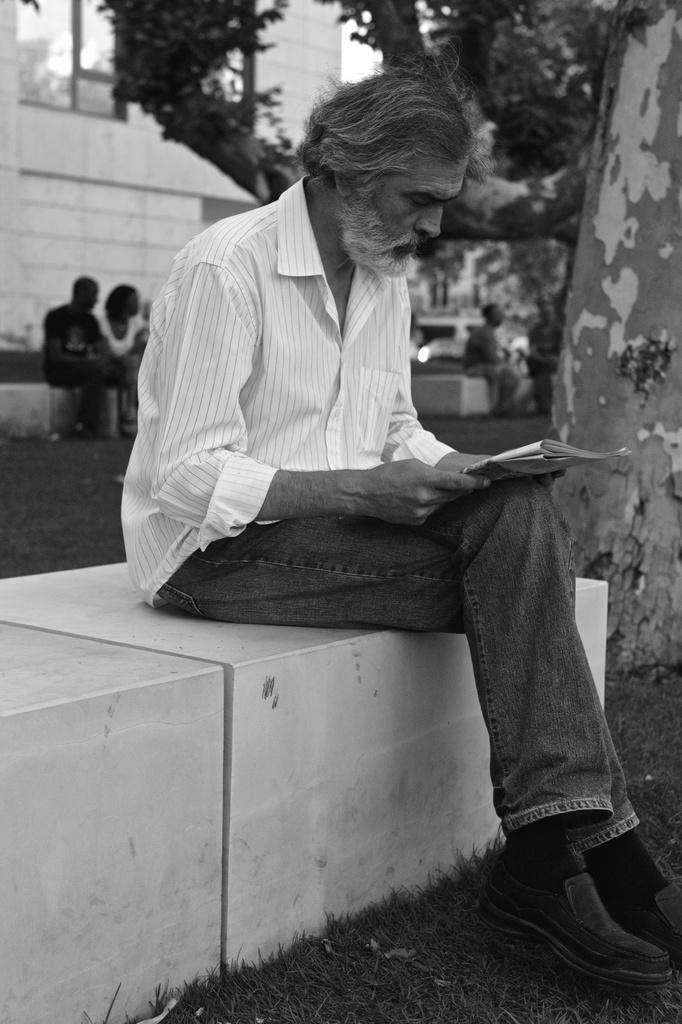Can you describe this image briefly? In the image I can see a person who is holding the paper and sitting and also I can see a building and a tree. 